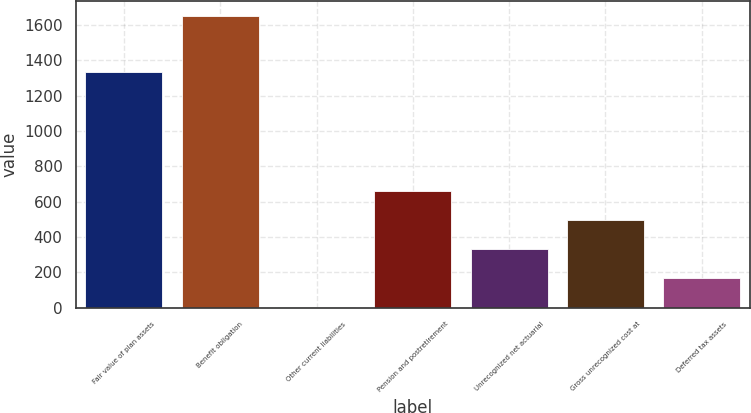Convert chart to OTSL. <chart><loc_0><loc_0><loc_500><loc_500><bar_chart><fcel>Fair value of plan assets<fcel>Benefit obligation<fcel>Other current liabilities<fcel>Pension and postretirement<fcel>Unrecognized net actuarial<fcel>Gross unrecognized cost at<fcel>Deferred tax assets<nl><fcel>1333<fcel>1651<fcel>5<fcel>663.4<fcel>334.2<fcel>498.8<fcel>169.6<nl></chart> 